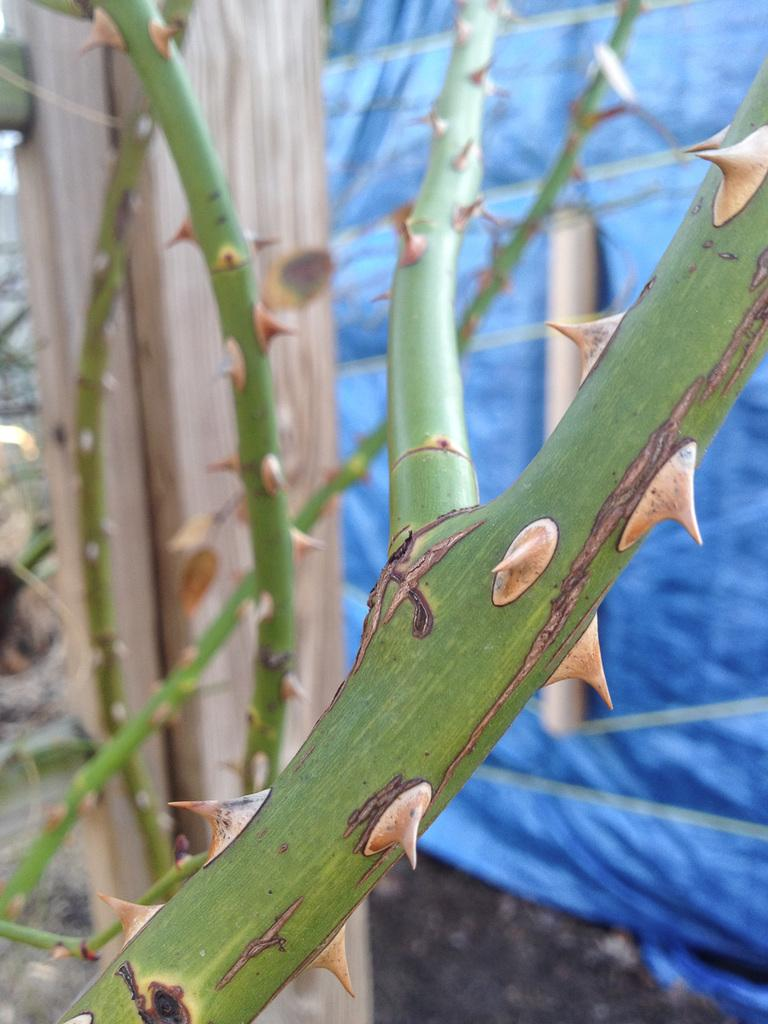What type of plant or vegetation is depicted in the image? There are thorny stems in the image. What color is the background of the image? The background of the image has a blue color cover. What is the base or foundation of the thorny stems? Soil is present in the image. What type of trucks are visible in the image? There are no trucks present in the image. Is there a baseball game happening in the image? There is no baseball game or any reference to baseball in the image. 